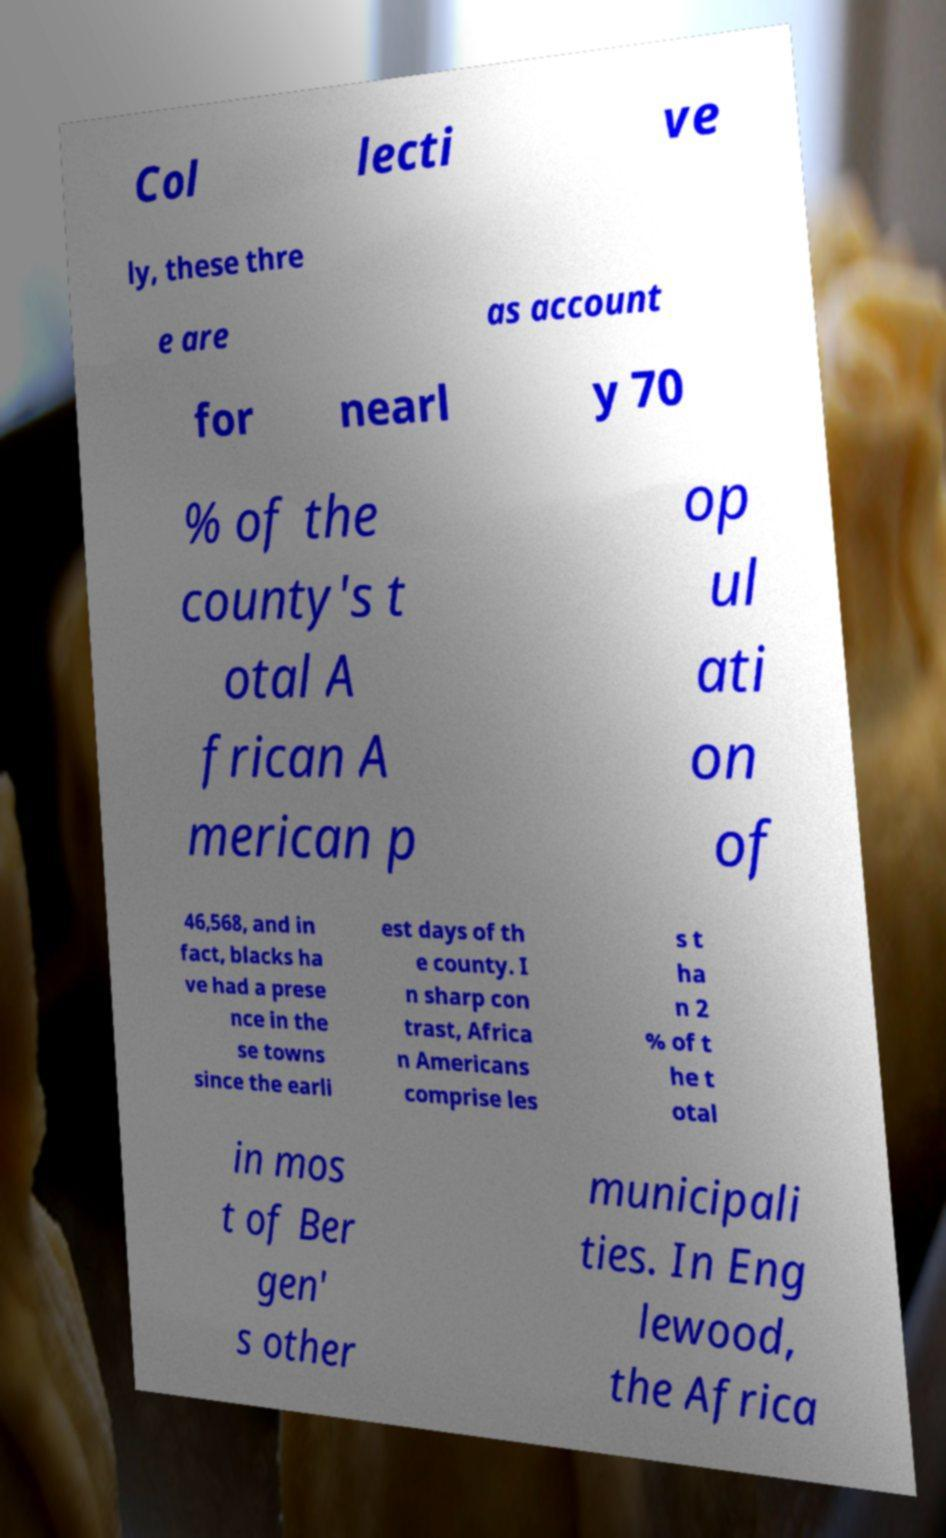Could you assist in decoding the text presented in this image and type it out clearly? Col lecti ve ly, these thre e are as account for nearl y 70 % of the county's t otal A frican A merican p op ul ati on of 46,568, and in fact, blacks ha ve had a prese nce in the se towns since the earli est days of th e county. I n sharp con trast, Africa n Americans comprise les s t ha n 2 % of t he t otal in mos t of Ber gen' s other municipali ties. In Eng lewood, the Africa 